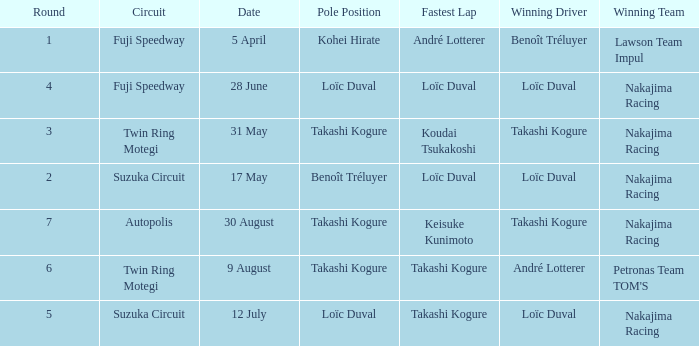What was the earlier round where Takashi Kogure got the fastest lap? 5.0. 